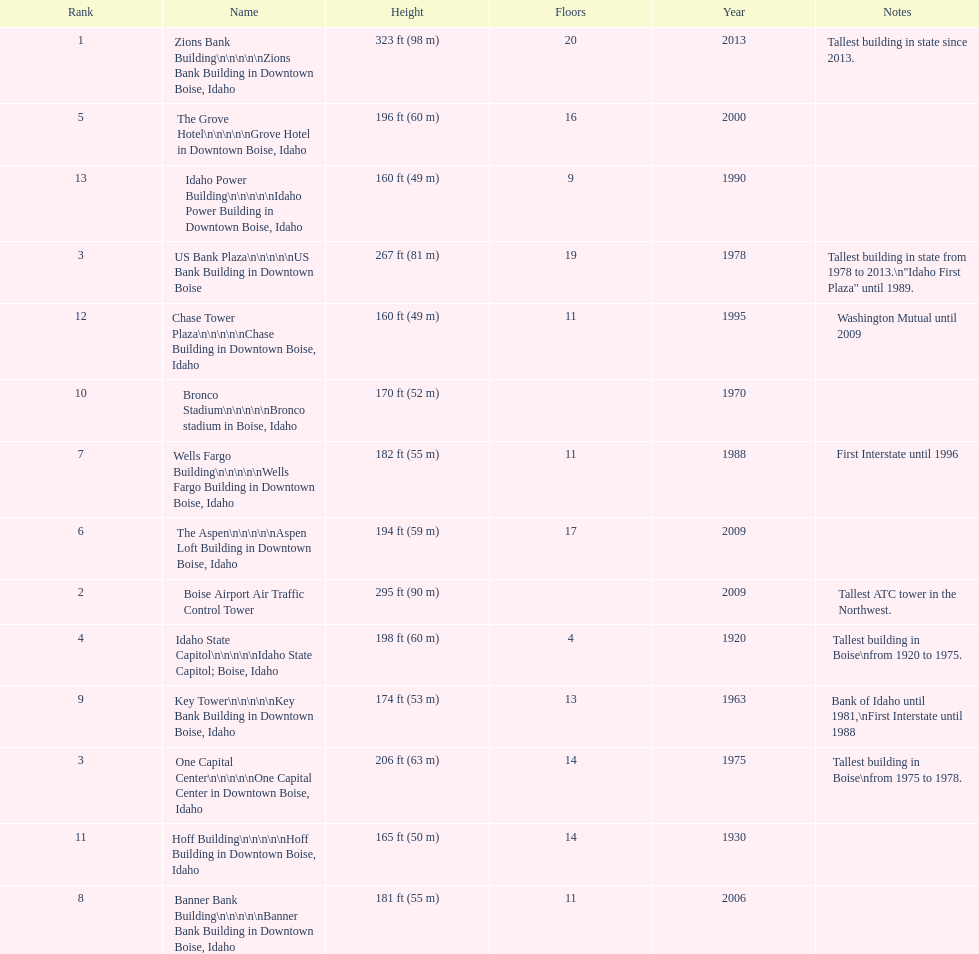What is the number of floors of the oldest building? 4. 